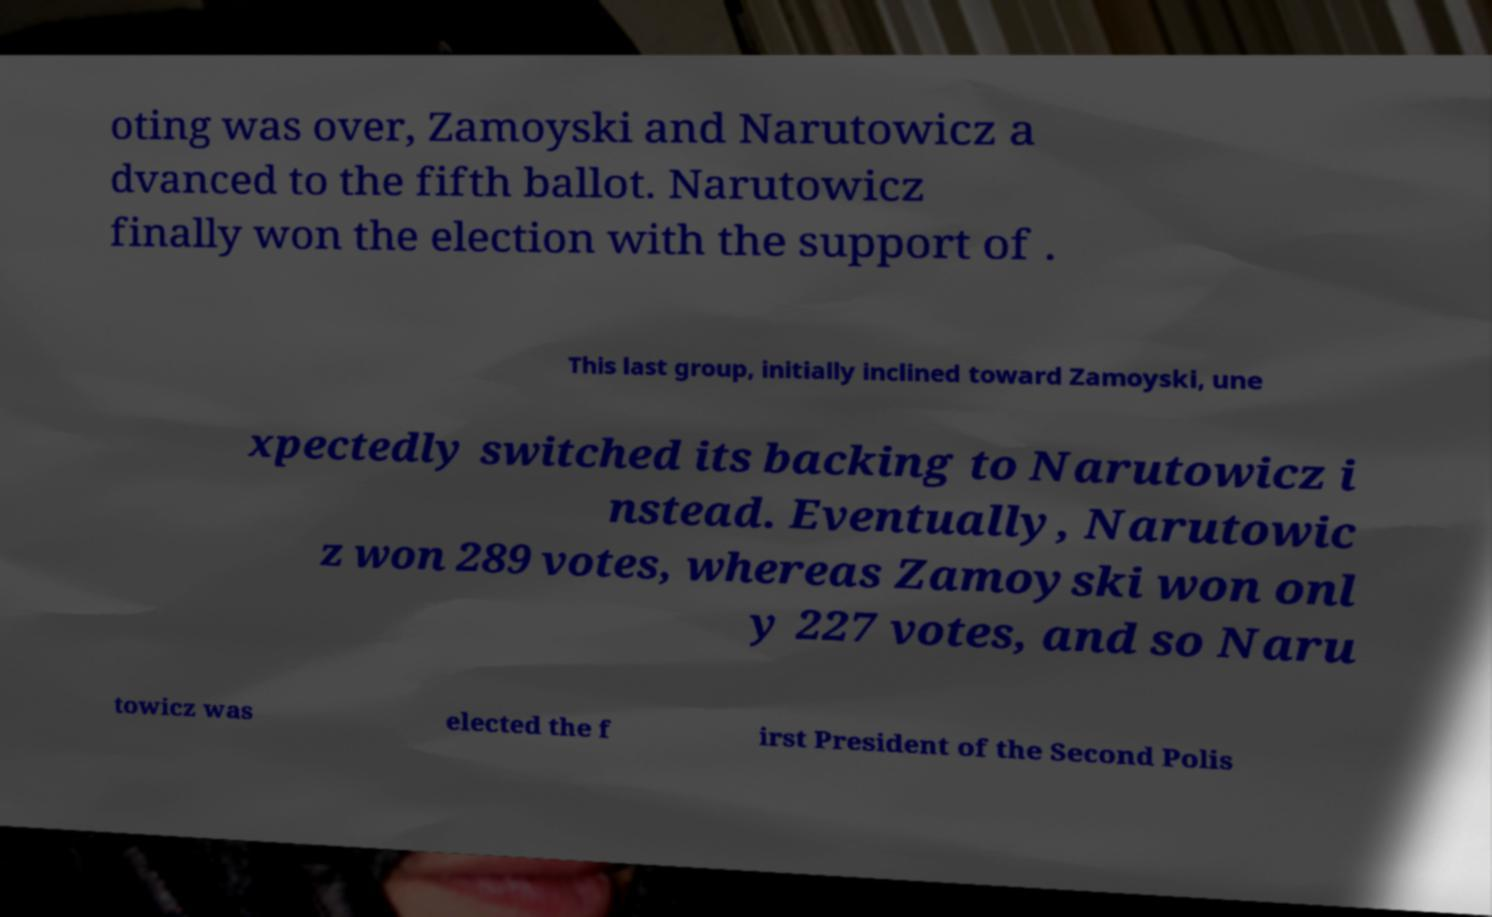Can you read and provide the text displayed in the image?This photo seems to have some interesting text. Can you extract and type it out for me? oting was over, Zamoyski and Narutowicz a dvanced to the fifth ballot. Narutowicz finally won the election with the support of . This last group, initially inclined toward Zamoyski, une xpectedly switched its backing to Narutowicz i nstead. Eventually, Narutowic z won 289 votes, whereas Zamoyski won onl y 227 votes, and so Naru towicz was elected the f irst President of the Second Polis 